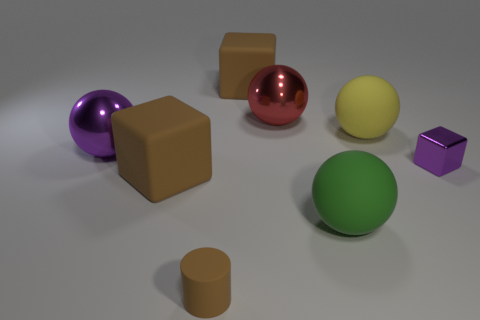What could be the purpose of these objects? These objects could serve educational purposes, like teaching about geometry, colors, and materials. Alternatively, they may be used in a visual arts context to study light reflection, shadows, and composition, or they could simply be part of a collection of toys or decorative items. 